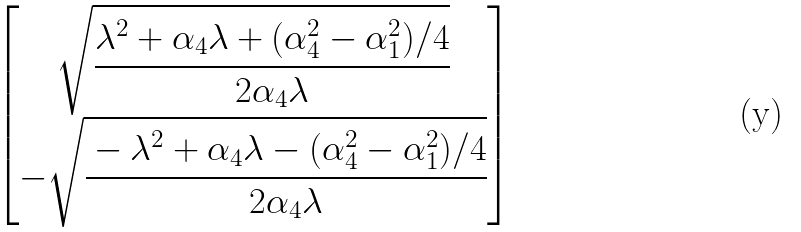Convert formula to latex. <formula><loc_0><loc_0><loc_500><loc_500>\begin{bmatrix} \sqrt { \cfrac { \lambda ^ { 2 } + \alpha _ { 4 } \lambda + ( \alpha _ { 4 } ^ { 2 } - \alpha _ { 1 } ^ { 2 } ) / 4 } { 2 \alpha _ { 4 } \lambda } } \\ - \sqrt { \cfrac { - \lambda ^ { 2 } + \alpha _ { 4 } \lambda - ( \alpha _ { 4 } ^ { 2 } - \alpha _ { 1 } ^ { 2 } ) / 4 } { 2 \alpha _ { 4 } \lambda } } \end{bmatrix}</formula> 